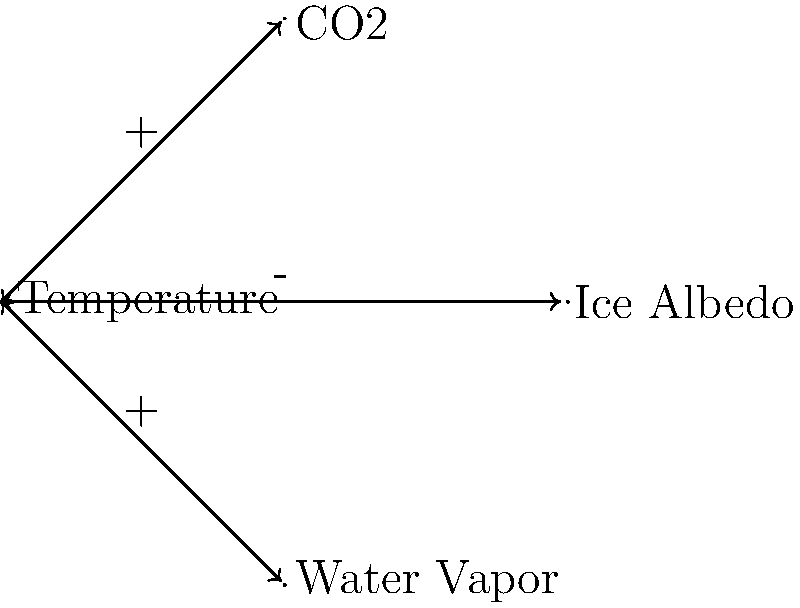Analyze the topological structure of the climate feedback loops shown in the diagram. How many positive feedback loops are present, and what potential impact do they have on the overall climate system? To answer this question, we need to analyze the feedback loops in the diagram:

1. Identify the loops:
   a) Temperature ↔ CO2
   b) Temperature ↔ Ice Albedo
   c) Temperature ↔ Water Vapor

2. Determine the nature of each loop:
   a) Temperature ↔ CO2: Both arrows are positive (+), so this is a positive feedback loop.
   b) Temperature ↔ Ice Albedo: Both arrows are negative (-), so this is a positive feedback loop.
   c) Temperature ↔ Water Vapor: Both arrows are positive (+), so this is a positive feedback loop.

3. Count the positive feedback loops:
   There are 3 positive feedback loops in total.

4. Analyze the impact:
   Positive feedback loops amplify changes in a system. In the context of climate:
   - The CO2 loop: Higher temperatures lead to more CO2 release, which further increases temperature.
   - The Ice Albedo loop: Higher temperatures melt ice, reducing reflectivity and absorbing more heat, further increasing temperature.
   - The Water Vapor loop: Higher temperatures increase water evaporation, and water vapor is a greenhouse gas, further increasing temperature.

5. Overall impact:
   These positive feedback loops can potentially lead to a runaway greenhouse effect, accelerating global warming beyond the direct effects of human-induced CO2 emissions.
Answer: 3 positive feedback loops; potential for accelerated global warming 